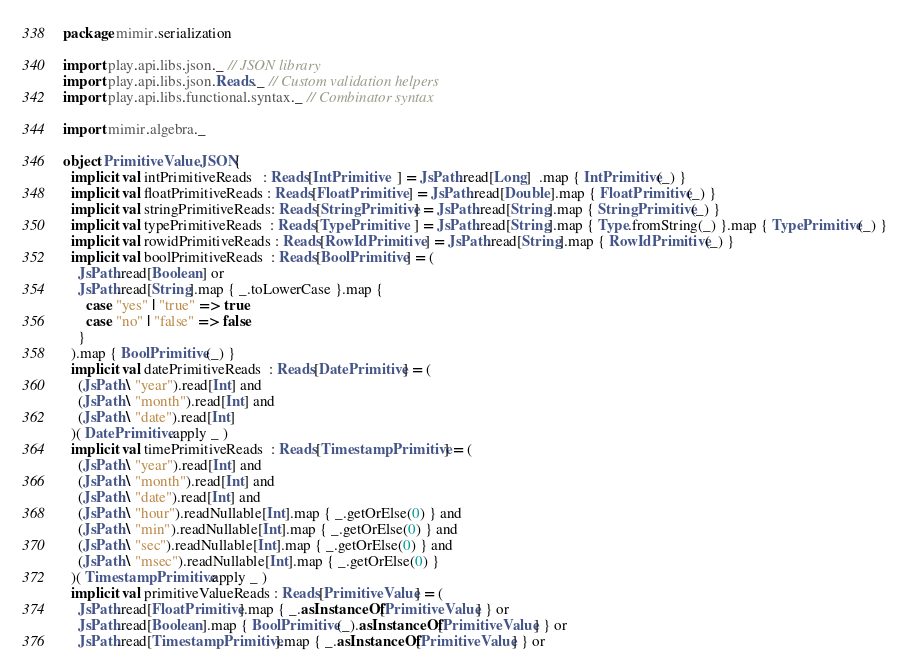Convert code to text. <code><loc_0><loc_0><loc_500><loc_500><_Scala_>package mimir.serialization

import play.api.libs.json._ // JSON library
import play.api.libs.json.Reads._ // Custom validation helpers
import play.api.libs.functional.syntax._ // Combinator syntax

import mimir.algebra._

object PrimitiveValueJSON { 
  implicit val intPrimitiveReads   : Reads[IntPrimitive   ] = JsPath.read[Long]  .map { IntPrimitive(_) }
  implicit val floatPrimitiveReads : Reads[FloatPrimitive ] = JsPath.read[Double].map { FloatPrimitive(_) }
  implicit val stringPrimitiveReads: Reads[StringPrimitive] = JsPath.read[String].map { StringPrimitive(_) }
  implicit val typePrimitiveReads  : Reads[TypePrimitive  ] = JsPath.read[String].map { Type.fromString(_) }.map { TypePrimitive(_) }
  implicit val rowidPrimitiveReads : Reads[RowIdPrimitive ] = JsPath.read[String].map { RowIdPrimitive(_) }
  implicit val boolPrimitiveReads  : Reads[BoolPrimitive] = (
    JsPath.read[Boolean] or
    JsPath.read[String].map { _.toLowerCase }.map { 
      case "yes" | "true" => true
      case "no" | "false" => false
    }
  ).map { BoolPrimitive(_) }
  implicit val datePrimitiveReads  : Reads[DatePrimitive] = (
    (JsPath \ "year").read[Int] and
    (JsPath \ "month").read[Int] and
    (JsPath \ "date").read[Int]
  )( DatePrimitive.apply _ )
  implicit val timePrimitiveReads  : Reads[TimestampPrimitive] = (
    (JsPath \ "year").read[Int] and
    (JsPath \ "month").read[Int] and
    (JsPath \ "date").read[Int] and
    (JsPath \ "hour").readNullable[Int].map { _.getOrElse(0) } and
    (JsPath \ "min").readNullable[Int].map { _.getOrElse(0) } and
    (JsPath \ "sec").readNullable[Int].map { _.getOrElse(0) } and
    (JsPath \ "msec").readNullable[Int].map { _.getOrElse(0) }
  )( TimestampPrimitive.apply _ )
  implicit val primitiveValueReads : Reads[PrimitiveValue] = (
    JsPath.read[FloatPrimitive].map { _.asInstanceOf[PrimitiveValue] } or 
    JsPath.read[Boolean].map { BoolPrimitive(_).asInstanceOf[PrimitiveValue] } or 
    JsPath.read[TimestampPrimitive].map { _.asInstanceOf[PrimitiveValue] } or</code> 